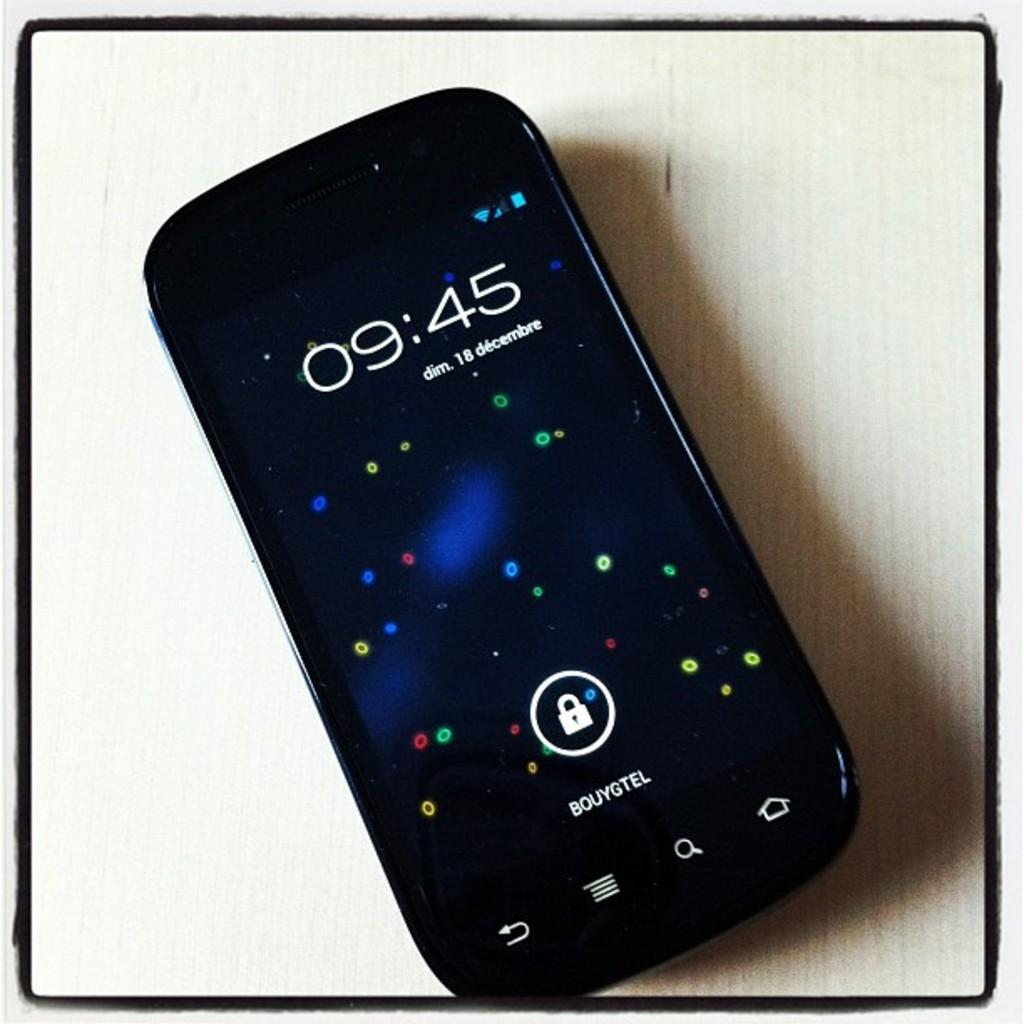<image>
Write a terse but informative summary of the picture. a bouygtel cell phone wit the time of 09;45 